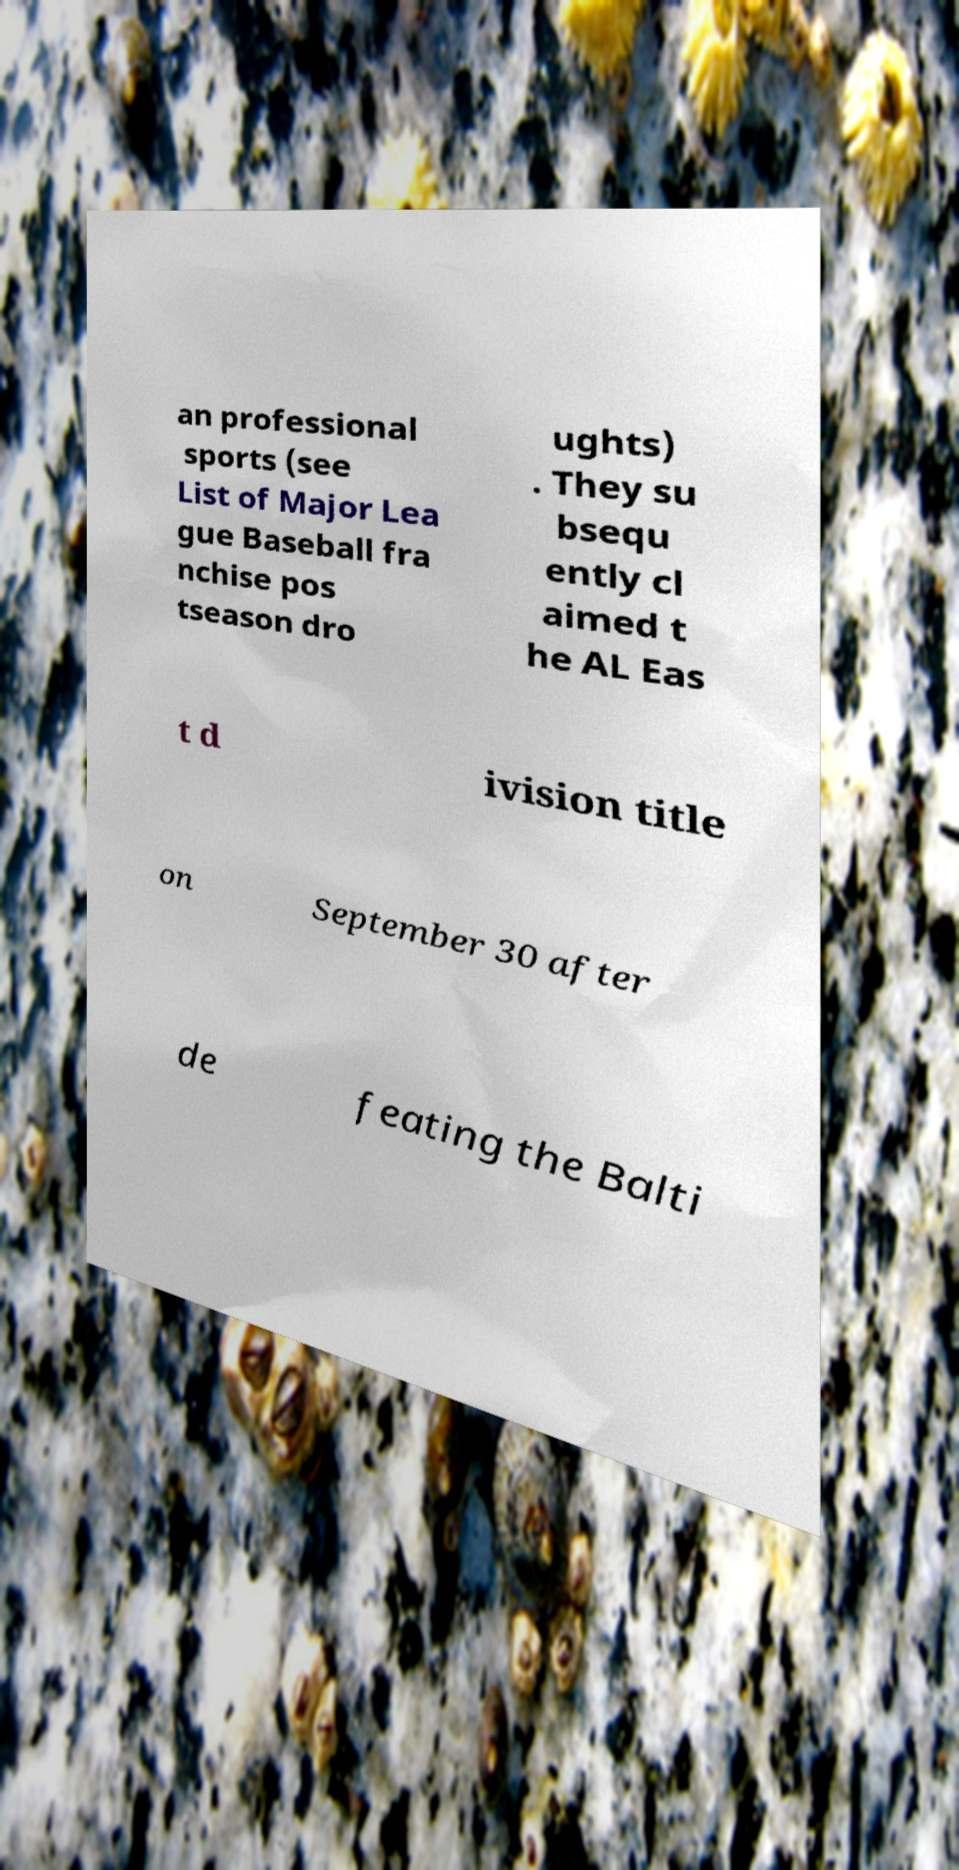There's text embedded in this image that I need extracted. Can you transcribe it verbatim? an professional sports (see List of Major Lea gue Baseball fra nchise pos tseason dro ughts) . They su bsequ ently cl aimed t he AL Eas t d ivision title on September 30 after de feating the Balti 